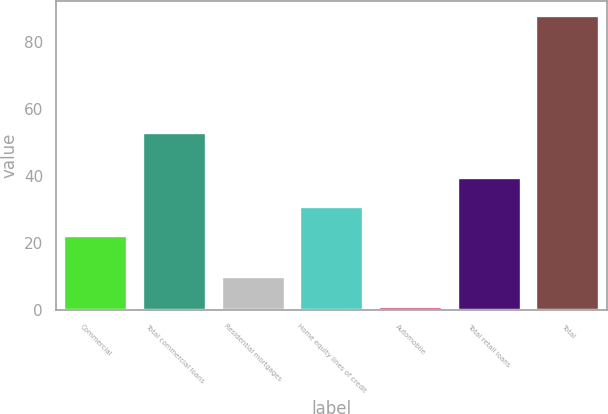<chart> <loc_0><loc_0><loc_500><loc_500><bar_chart><fcel>Commercial<fcel>Total commercial loans<fcel>Residential mortgages<fcel>Home equity lines of credit<fcel>Automobile<fcel>Total retail loans<fcel>Total<nl><fcel>22<fcel>53<fcel>9.7<fcel>30.7<fcel>1<fcel>39.4<fcel>88<nl></chart> 